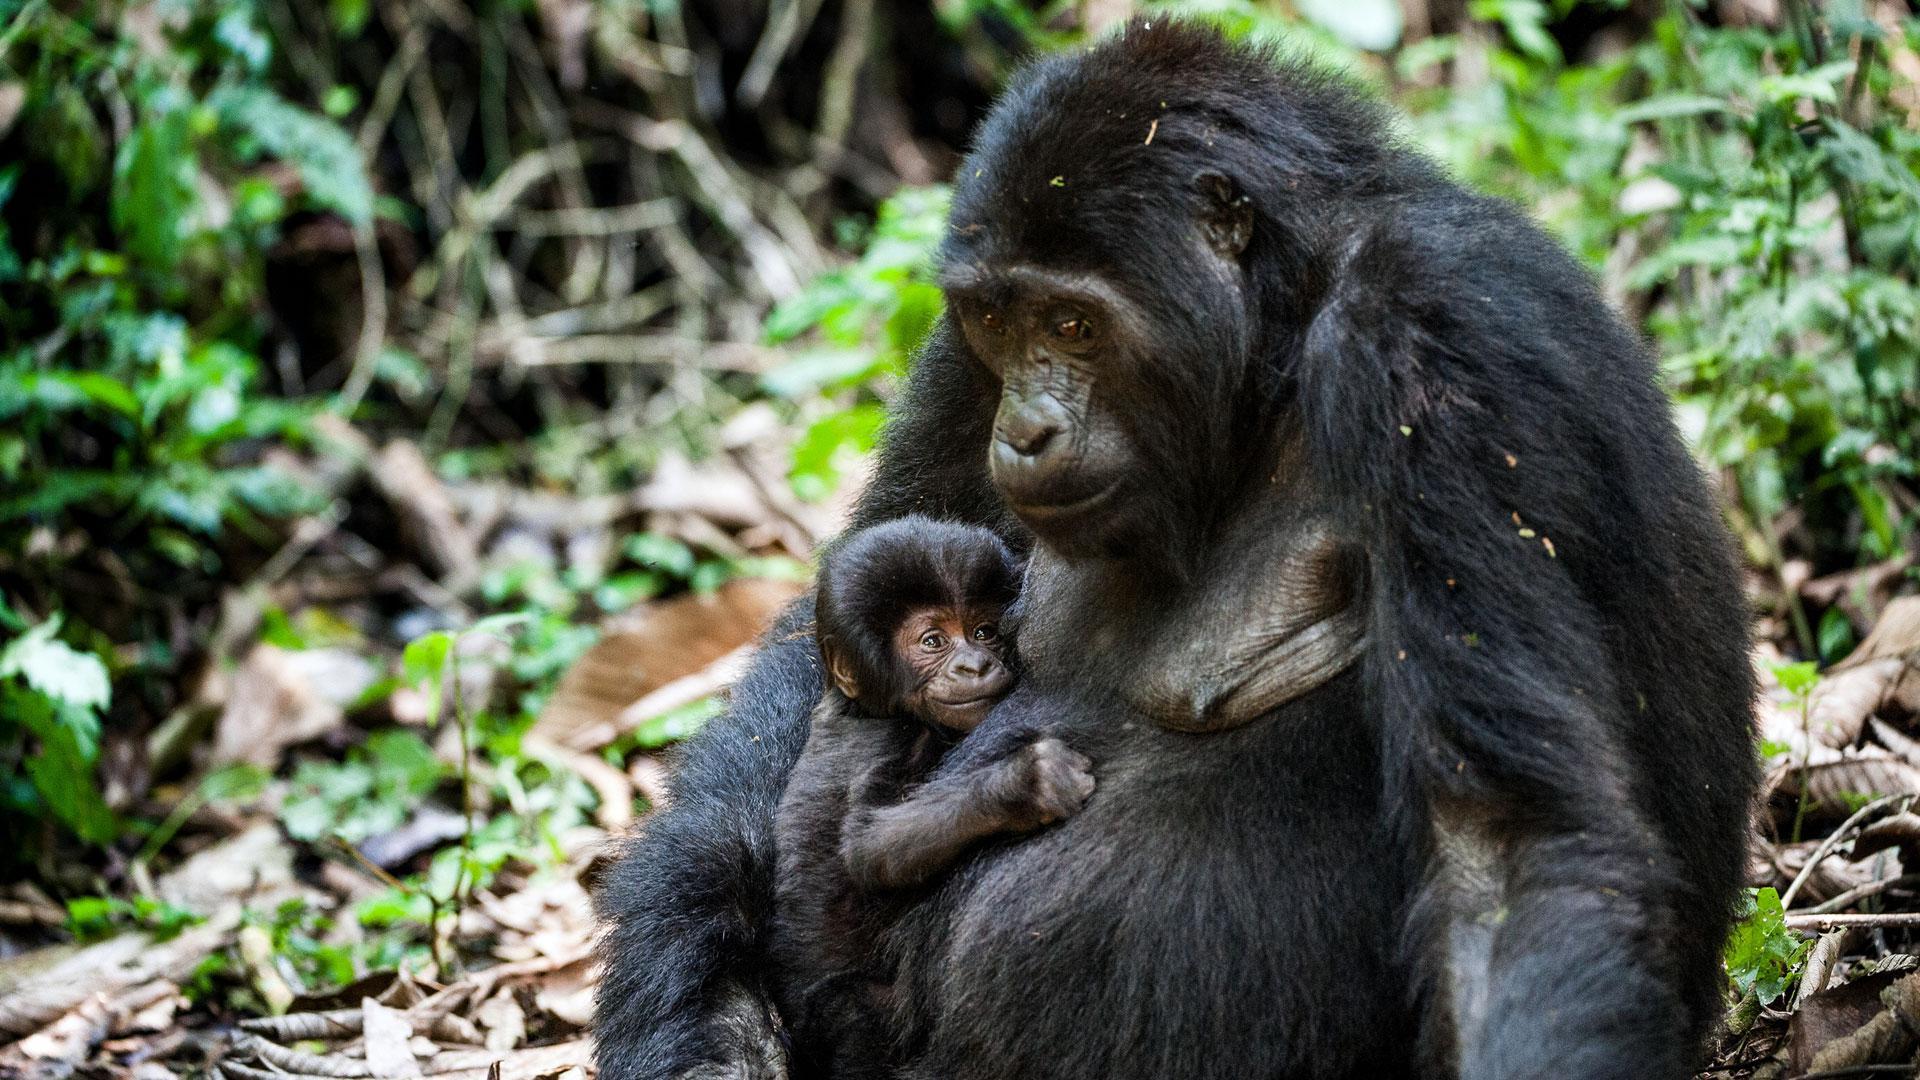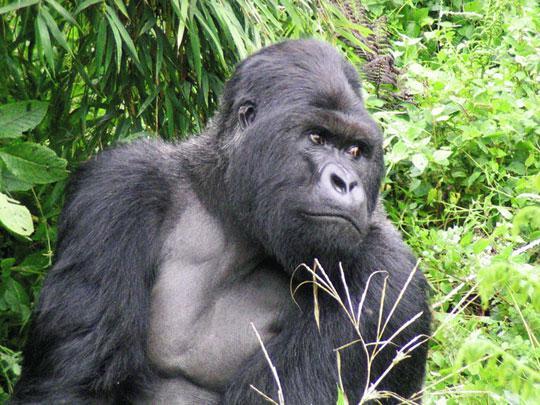The first image is the image on the left, the second image is the image on the right. Given the left and right images, does the statement "There are two gorillas in one picture and one in the other." hold true? Answer yes or no. Yes. The first image is the image on the left, the second image is the image on the right. For the images shown, is this caption "The left image shows one adult gorilla on all fours, and the right image shows one adult gorilla with a frowning face looking directly at the camera." true? Answer yes or no. No. 